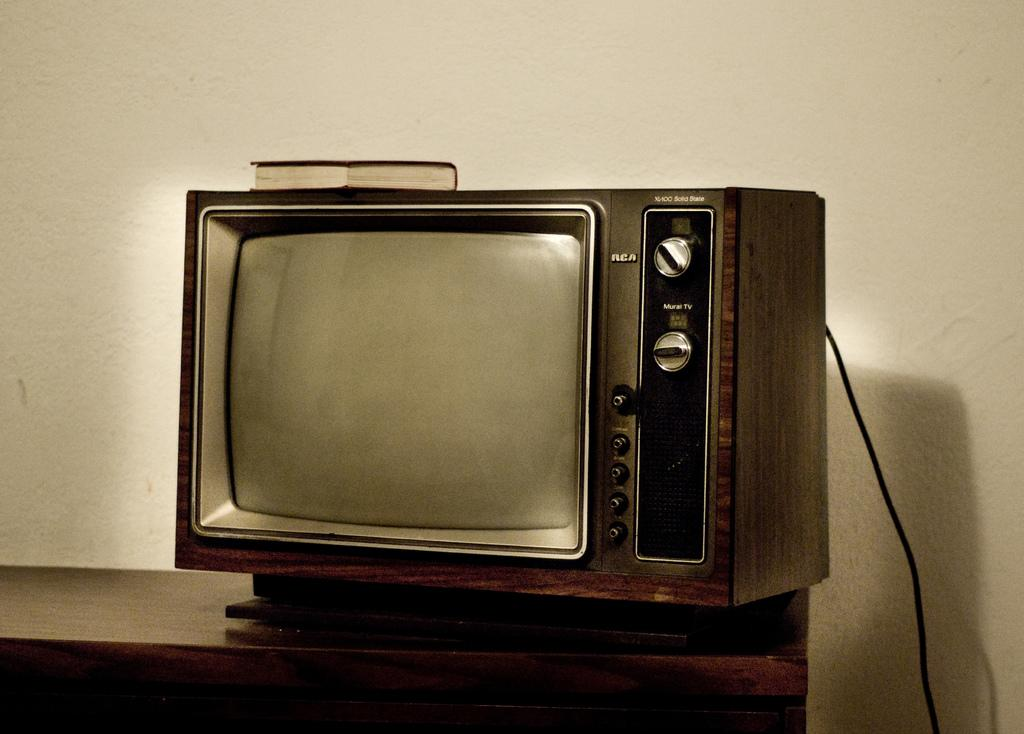<image>
Write a terse but informative summary of the picture. A very old fashioned television with the letters RCA on the front 